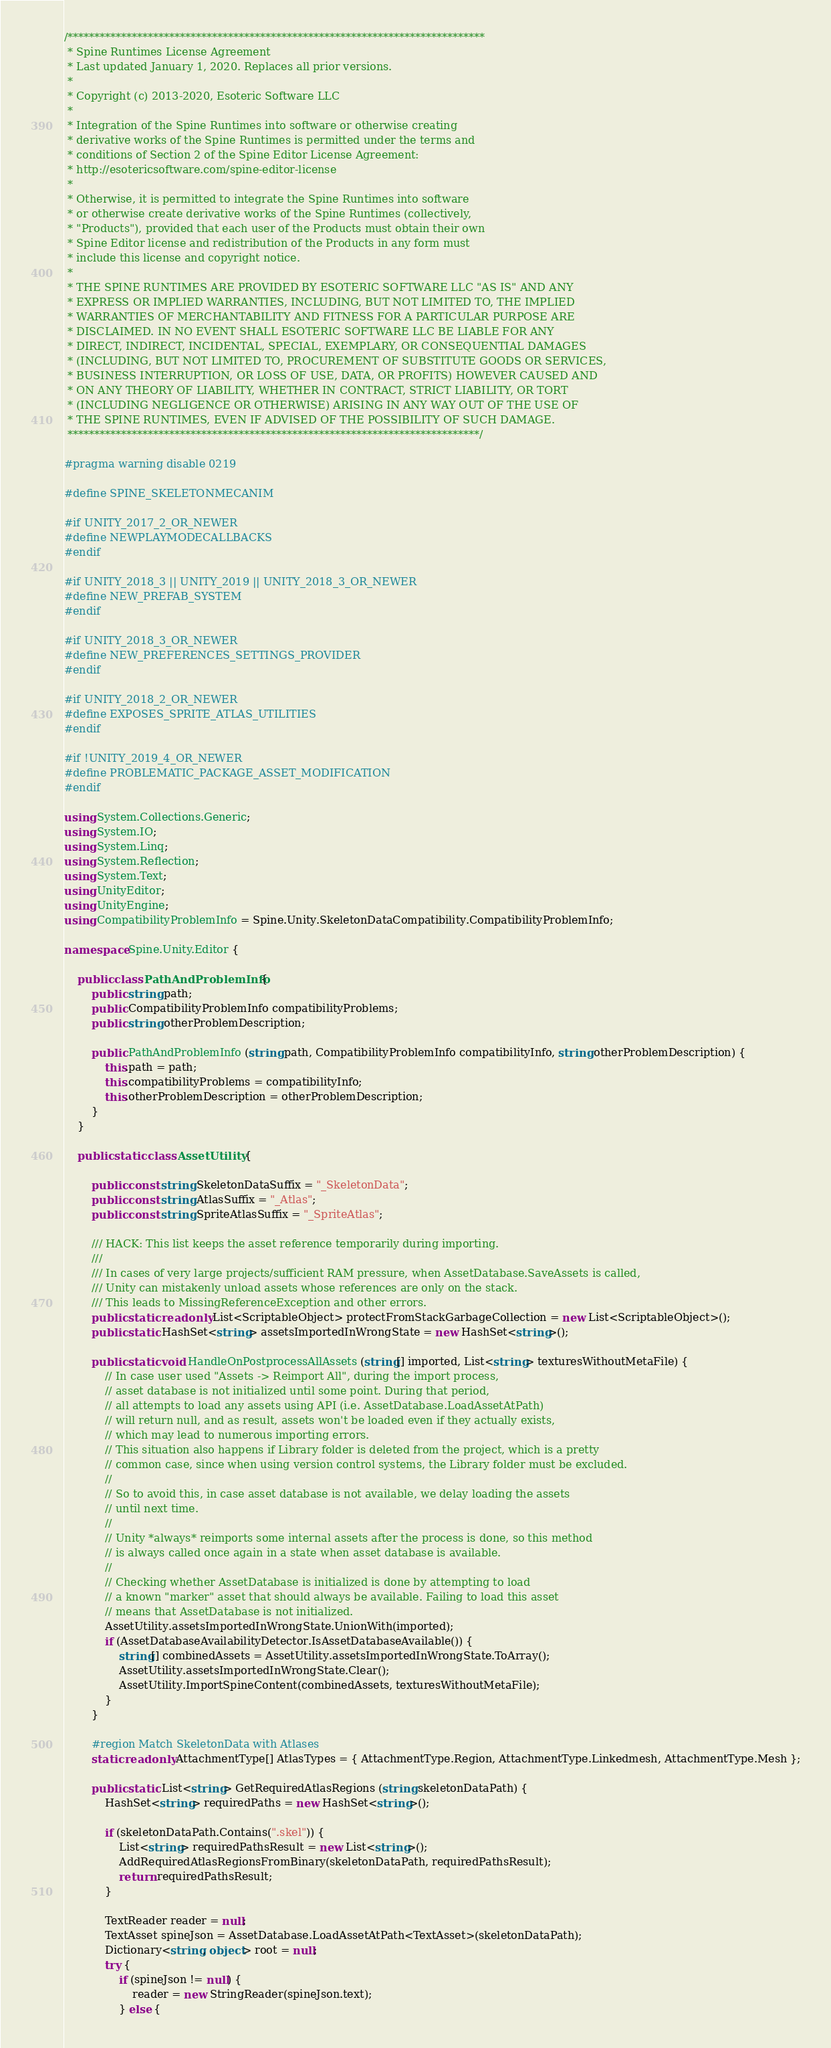<code> <loc_0><loc_0><loc_500><loc_500><_C#_>/******************************************************************************
 * Spine Runtimes License Agreement
 * Last updated January 1, 2020. Replaces all prior versions.
 *
 * Copyright (c) 2013-2020, Esoteric Software LLC
 *
 * Integration of the Spine Runtimes into software or otherwise creating
 * derivative works of the Spine Runtimes is permitted under the terms and
 * conditions of Section 2 of the Spine Editor License Agreement:
 * http://esotericsoftware.com/spine-editor-license
 *
 * Otherwise, it is permitted to integrate the Spine Runtimes into software
 * or otherwise create derivative works of the Spine Runtimes (collectively,
 * "Products"), provided that each user of the Products must obtain their own
 * Spine Editor license and redistribution of the Products in any form must
 * include this license and copyright notice.
 *
 * THE SPINE RUNTIMES ARE PROVIDED BY ESOTERIC SOFTWARE LLC "AS IS" AND ANY
 * EXPRESS OR IMPLIED WARRANTIES, INCLUDING, BUT NOT LIMITED TO, THE IMPLIED
 * WARRANTIES OF MERCHANTABILITY AND FITNESS FOR A PARTICULAR PURPOSE ARE
 * DISCLAIMED. IN NO EVENT SHALL ESOTERIC SOFTWARE LLC BE LIABLE FOR ANY
 * DIRECT, INDIRECT, INCIDENTAL, SPECIAL, EXEMPLARY, OR CONSEQUENTIAL DAMAGES
 * (INCLUDING, BUT NOT LIMITED TO, PROCUREMENT OF SUBSTITUTE GOODS OR SERVICES,
 * BUSINESS INTERRUPTION, OR LOSS OF USE, DATA, OR PROFITS) HOWEVER CAUSED AND
 * ON ANY THEORY OF LIABILITY, WHETHER IN CONTRACT, STRICT LIABILITY, OR TORT
 * (INCLUDING NEGLIGENCE OR OTHERWISE) ARISING IN ANY WAY OUT OF THE USE OF
 * THE SPINE RUNTIMES, EVEN IF ADVISED OF THE POSSIBILITY OF SUCH DAMAGE.
 *****************************************************************************/

#pragma warning disable 0219

#define SPINE_SKELETONMECANIM

#if UNITY_2017_2_OR_NEWER
#define NEWPLAYMODECALLBACKS
#endif

#if UNITY_2018_3 || UNITY_2019 || UNITY_2018_3_OR_NEWER
#define NEW_PREFAB_SYSTEM
#endif

#if UNITY_2018_3_OR_NEWER
#define NEW_PREFERENCES_SETTINGS_PROVIDER
#endif

#if UNITY_2018_2_OR_NEWER
#define EXPOSES_SPRITE_ATLAS_UTILITIES
#endif

#if !UNITY_2019_4_OR_NEWER
#define PROBLEMATIC_PACKAGE_ASSET_MODIFICATION
#endif

using System.Collections.Generic;
using System.IO;
using System.Linq;
using System.Reflection;
using System.Text;
using UnityEditor;
using UnityEngine;
using CompatibilityProblemInfo = Spine.Unity.SkeletonDataCompatibility.CompatibilityProblemInfo;

namespace Spine.Unity.Editor {

	public class PathAndProblemInfo {
		public string path;
		public CompatibilityProblemInfo compatibilityProblems;
		public string otherProblemDescription;

		public PathAndProblemInfo (string path, CompatibilityProblemInfo compatibilityInfo, string otherProblemDescription) {
			this.path = path;
			this.compatibilityProblems = compatibilityInfo;
			this.otherProblemDescription = otherProblemDescription;
		}
	}

	public static class AssetUtility {

		public const string SkeletonDataSuffix = "_SkeletonData";
		public const string AtlasSuffix = "_Atlas";
		public const string SpriteAtlasSuffix = "_SpriteAtlas";

		/// HACK: This list keeps the asset reference temporarily during importing.
		///
		/// In cases of very large projects/sufficient RAM pressure, when AssetDatabase.SaveAssets is called,
		/// Unity can mistakenly unload assets whose references are only on the stack.
		/// This leads to MissingReferenceException and other errors.
		public static readonly List<ScriptableObject> protectFromStackGarbageCollection = new List<ScriptableObject>();
		public static HashSet<string> assetsImportedInWrongState = new HashSet<string>();

		public static void HandleOnPostprocessAllAssets (string[] imported, List<string> texturesWithoutMetaFile) {
			// In case user used "Assets -> Reimport All", during the import process,
			// asset database is not initialized until some point. During that period,
			// all attempts to load any assets using API (i.e. AssetDatabase.LoadAssetAtPath)
			// will return null, and as result, assets won't be loaded even if they actually exists,
			// which may lead to numerous importing errors.
			// This situation also happens if Library folder is deleted from the project, which is a pretty
			// common case, since when using version control systems, the Library folder must be excluded.
			//
			// So to avoid this, in case asset database is not available, we delay loading the assets
			// until next time.
			//
			// Unity *always* reimports some internal assets after the process is done, so this method
			// is always called once again in a state when asset database is available.
			//
			// Checking whether AssetDatabase is initialized is done by attempting to load
			// a known "marker" asset that should always be available. Failing to load this asset
			// means that AssetDatabase is not initialized.
			AssetUtility.assetsImportedInWrongState.UnionWith(imported);
			if (AssetDatabaseAvailabilityDetector.IsAssetDatabaseAvailable()) {
				string[] combinedAssets = AssetUtility.assetsImportedInWrongState.ToArray();
				AssetUtility.assetsImportedInWrongState.Clear();
				AssetUtility.ImportSpineContent(combinedAssets, texturesWithoutMetaFile);
			}
		}

		#region Match SkeletonData with Atlases
		static readonly AttachmentType[] AtlasTypes = { AttachmentType.Region, AttachmentType.Linkedmesh, AttachmentType.Mesh };

		public static List<string> GetRequiredAtlasRegions (string skeletonDataPath) {
			HashSet<string> requiredPaths = new HashSet<string>();

			if (skeletonDataPath.Contains(".skel")) {
				List<string> requiredPathsResult = new List<string>();
				AddRequiredAtlasRegionsFromBinary(skeletonDataPath, requiredPathsResult);
				return requiredPathsResult;
			}

			TextReader reader = null;
			TextAsset spineJson = AssetDatabase.LoadAssetAtPath<TextAsset>(skeletonDataPath);
			Dictionary<string, object> root = null;
			try {
				if (spineJson != null) {
					reader = new StringReader(spineJson.text);
				} else {</code> 